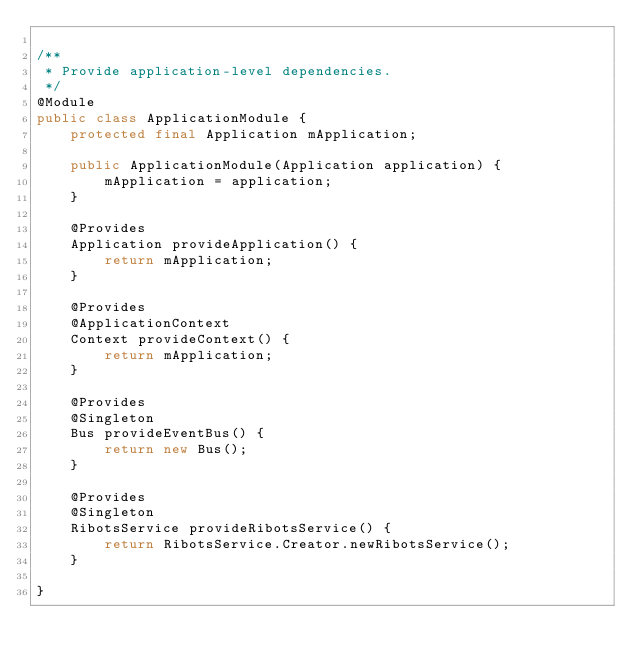Convert code to text. <code><loc_0><loc_0><loc_500><loc_500><_Java_>
/**
 * Provide application-level dependencies.
 */
@Module
public class ApplicationModule {
    protected final Application mApplication;

    public ApplicationModule(Application application) {
        mApplication = application;
    }

    @Provides
    Application provideApplication() {
        return mApplication;
    }

    @Provides
    @ApplicationContext
    Context provideContext() {
        return mApplication;
    }

    @Provides
    @Singleton
    Bus provideEventBus() {
        return new Bus();
    }

    @Provides
    @Singleton
    RibotsService provideRibotsService() {
        return RibotsService.Creator.newRibotsService();
    }

}
</code> 